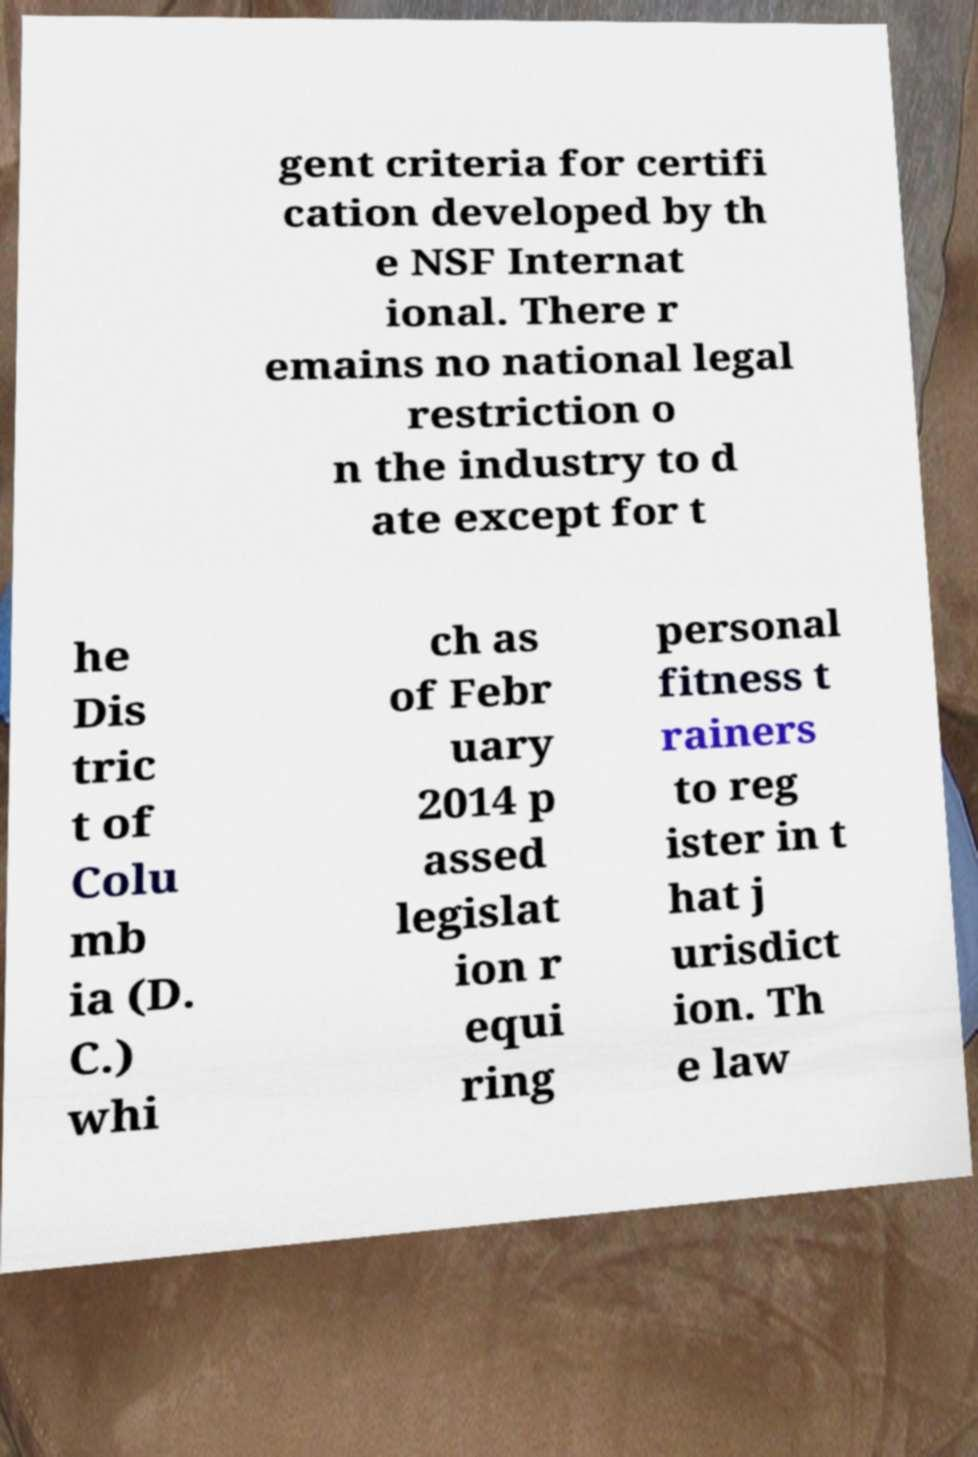Could you assist in decoding the text presented in this image and type it out clearly? gent criteria for certifi cation developed by th e NSF Internat ional. There r emains no national legal restriction o n the industry to d ate except for t he Dis tric t of Colu mb ia (D. C.) whi ch as of Febr uary 2014 p assed legislat ion r equi ring personal fitness t rainers to reg ister in t hat j urisdict ion. Th e law 